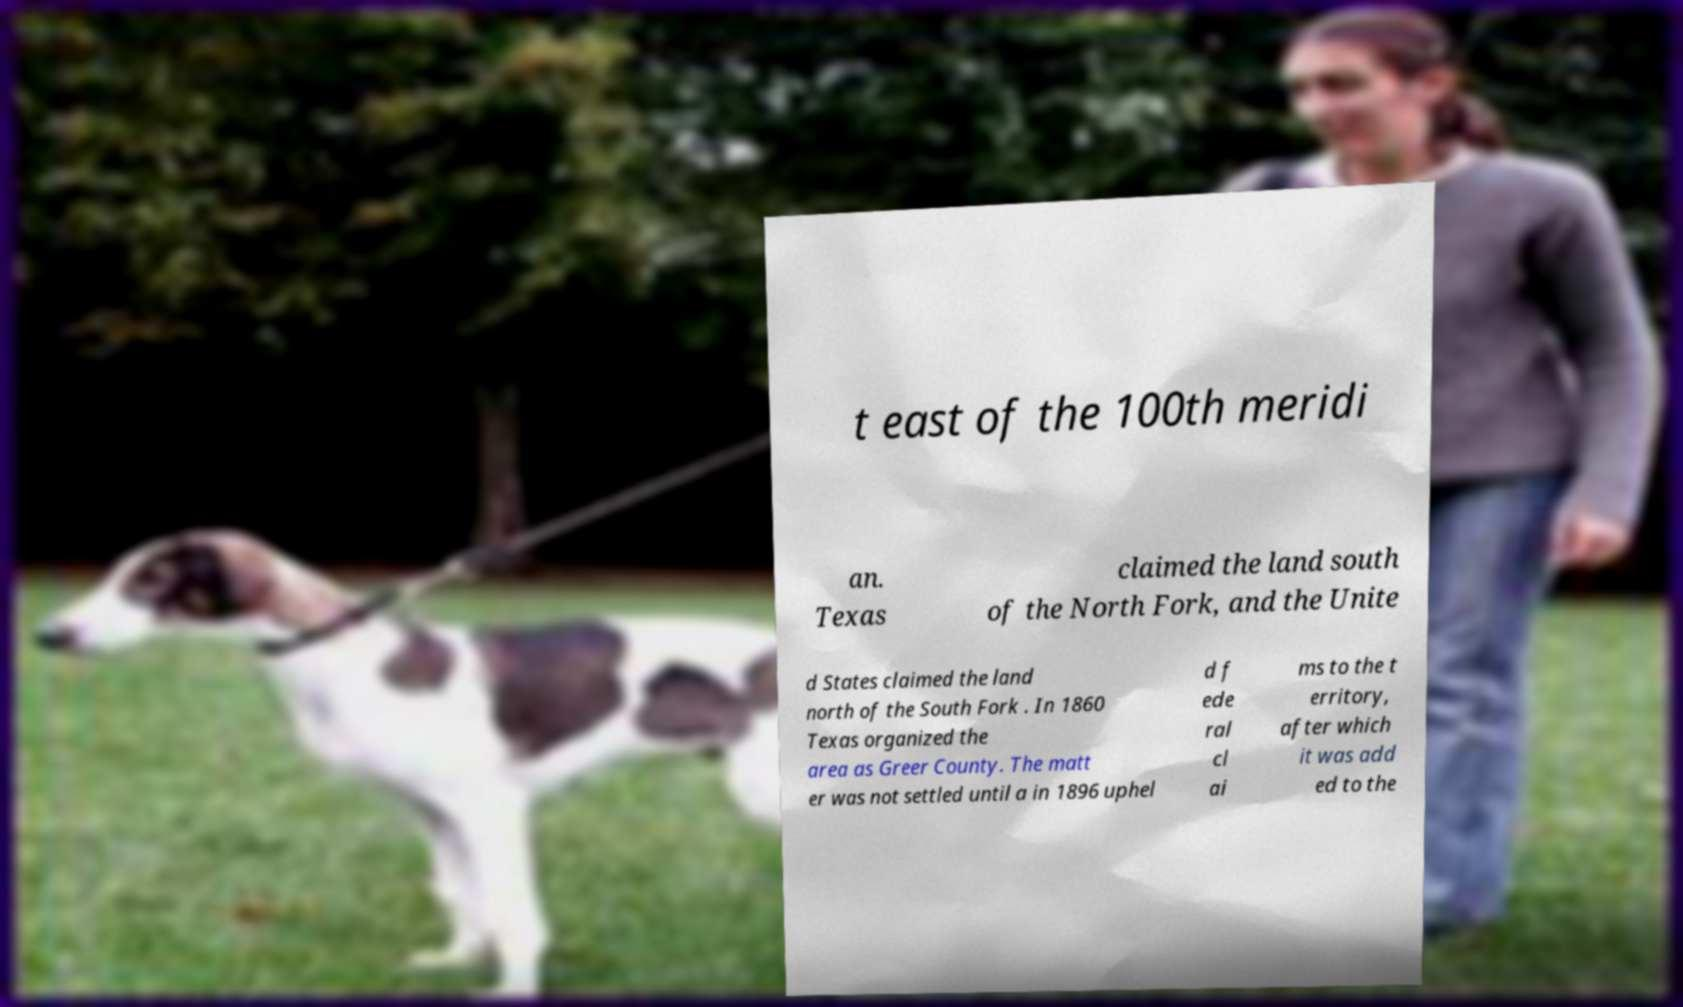For documentation purposes, I need the text within this image transcribed. Could you provide that? t east of the 100th meridi an. Texas claimed the land south of the North Fork, and the Unite d States claimed the land north of the South Fork . In 1860 Texas organized the area as Greer County. The matt er was not settled until a in 1896 uphel d f ede ral cl ai ms to the t erritory, after which it was add ed to the 